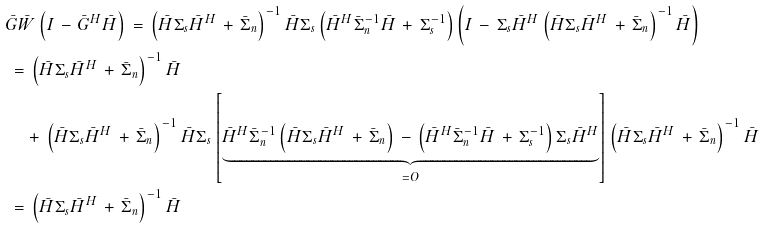<formula> <loc_0><loc_0><loc_500><loc_500>\, & \bar { G } \bar { W } \left ( I \, - \, \bar { G } ^ { H } \bar { H } \right ) \, = \, \left ( \bar { H } \Sigma _ { s } \bar { H } ^ { H } \, + \, \bar { \Sigma } _ { n } \right ) ^ { - 1 } \bar { H } \Sigma _ { s } \left ( \bar { H } ^ { H } \bar { \Sigma } _ { n } ^ { - 1 } \bar { H } \, + \, \Sigma _ { s } ^ { - 1 } \right ) \left ( I \, - \, \Sigma _ { s } \bar { H } ^ { H } \left ( \bar { H } \Sigma _ { s } \bar { H } ^ { H } \, + \, \bar { \Sigma } _ { n } \right ) ^ { - 1 } \bar { H } \right ) \\ \, & \, = \, \left ( \bar { H } \Sigma _ { s } \bar { H } ^ { H } \, + \, \bar { \Sigma } _ { n } \right ) ^ { - 1 } \bar { H } \\ \, & \quad \, + \, \left ( \bar { H } \Sigma _ { s } \bar { H } ^ { H } \, + \, \bar { \Sigma } _ { n } \right ) ^ { - 1 } \bar { H } \Sigma _ { s } \left [ \underbrace { \bar { H } ^ { H } \bar { \Sigma } _ { n } ^ { - 1 } \left ( \bar { H } \Sigma _ { s } \bar { H } ^ { H } \, + \, \bar { \Sigma } _ { n } \right ) \, - \, \left ( \bar { H } ^ { H } \bar { \Sigma } _ { n } ^ { - 1 } \bar { H } \, + \, \Sigma _ { s } ^ { - 1 } \right ) \Sigma _ { s } \bar { H } ^ { H } } _ { = O } \right ] \left ( \bar { H } \Sigma _ { s } \bar { H } ^ { H } \, + \, \bar { \Sigma } _ { n } \right ) ^ { - 1 } \bar { H } \\ \, & \, = \, \left ( \bar { H } \Sigma _ { s } \bar { H } ^ { H } \, + \, \bar { \Sigma } _ { n } \right ) ^ { - 1 } \bar { H }</formula> 